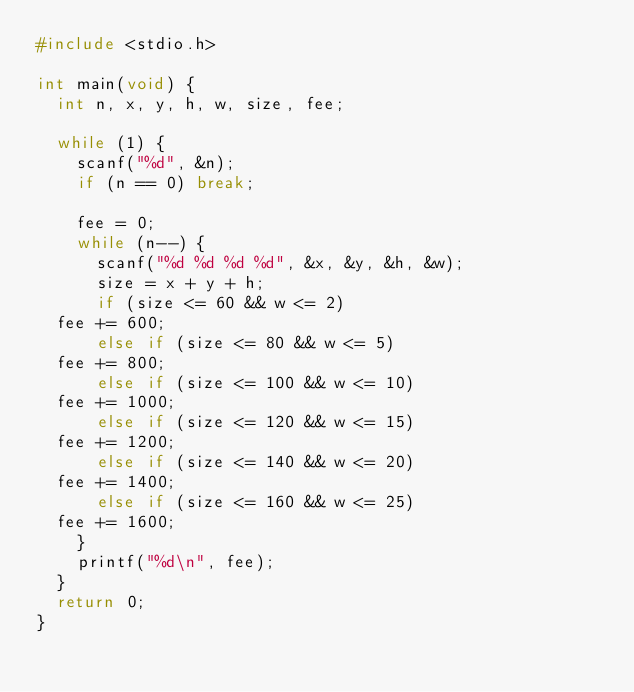<code> <loc_0><loc_0><loc_500><loc_500><_C_>#include <stdio.h>

int main(void) {
  int n, x, y, h, w, size, fee;

  while (1) {
    scanf("%d", &n);
    if (n == 0) break;

    fee = 0;
    while (n--) {
      scanf("%d %d %d %d", &x, &y, &h, &w);
      size = x + y + h;
      if (size <= 60 && w <= 2)
	fee += 600;
      else if (size <= 80 && w <= 5)
	fee += 800;
      else if (size <= 100 && w <= 10)
	fee += 1000;
      else if (size <= 120 && w <= 15)
	fee += 1200;
      else if (size <= 140 && w <= 20)
	fee += 1400;
      else if (size <= 160 && w <= 25)
	fee += 1600;
    }
    printf("%d\n", fee);
  }
  return 0;
}</code> 